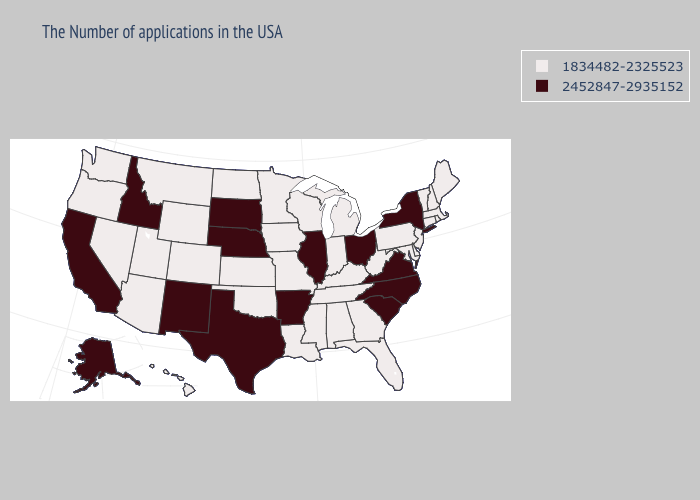Which states have the lowest value in the West?
Concise answer only. Wyoming, Colorado, Utah, Montana, Arizona, Nevada, Washington, Oregon, Hawaii. Name the states that have a value in the range 1834482-2325523?
Concise answer only. Maine, Massachusetts, Rhode Island, New Hampshire, Vermont, Connecticut, New Jersey, Delaware, Maryland, Pennsylvania, West Virginia, Florida, Georgia, Michigan, Kentucky, Indiana, Alabama, Tennessee, Wisconsin, Mississippi, Louisiana, Missouri, Minnesota, Iowa, Kansas, Oklahoma, North Dakota, Wyoming, Colorado, Utah, Montana, Arizona, Nevada, Washington, Oregon, Hawaii. What is the highest value in states that border Indiana?
Give a very brief answer. 2452847-2935152. What is the value of Illinois?
Answer briefly. 2452847-2935152. Does Utah have the lowest value in the USA?
Quick response, please. Yes. Does California have the lowest value in the USA?
Write a very short answer. No. Does Utah have a lower value than Colorado?
Answer briefly. No. Does New York have the lowest value in the USA?
Short answer required. No. Does Missouri have a lower value than New Mexico?
Answer briefly. Yes. Does Nebraska have the highest value in the USA?
Be succinct. Yes. What is the value of Rhode Island?
Concise answer only. 1834482-2325523. What is the value of Montana?
Answer briefly. 1834482-2325523. Which states have the highest value in the USA?
Quick response, please. New York, Virginia, North Carolina, South Carolina, Ohio, Illinois, Arkansas, Nebraska, Texas, South Dakota, New Mexico, Idaho, California, Alaska. How many symbols are there in the legend?
Write a very short answer. 2. 